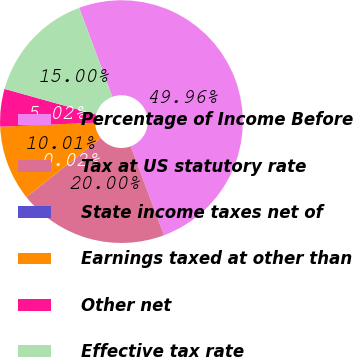<chart> <loc_0><loc_0><loc_500><loc_500><pie_chart><fcel>Percentage of Income Before<fcel>Tax at US statutory rate<fcel>State income taxes net of<fcel>Earnings taxed at other than<fcel>Other net<fcel>Effective tax rate<nl><fcel>49.96%<fcel>20.0%<fcel>0.02%<fcel>10.01%<fcel>5.02%<fcel>15.0%<nl></chart> 